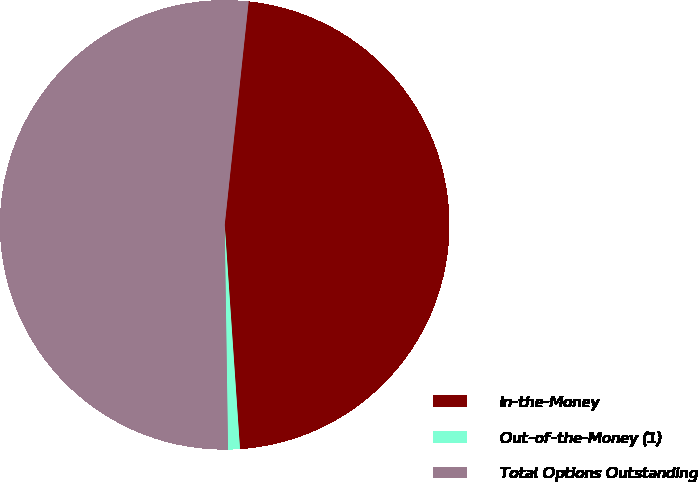Convert chart to OTSL. <chart><loc_0><loc_0><loc_500><loc_500><pie_chart><fcel>In-the-Money<fcel>Out-of-the-Money (1)<fcel>Total Options Outstanding<nl><fcel>47.22%<fcel>0.85%<fcel>51.94%<nl></chart> 